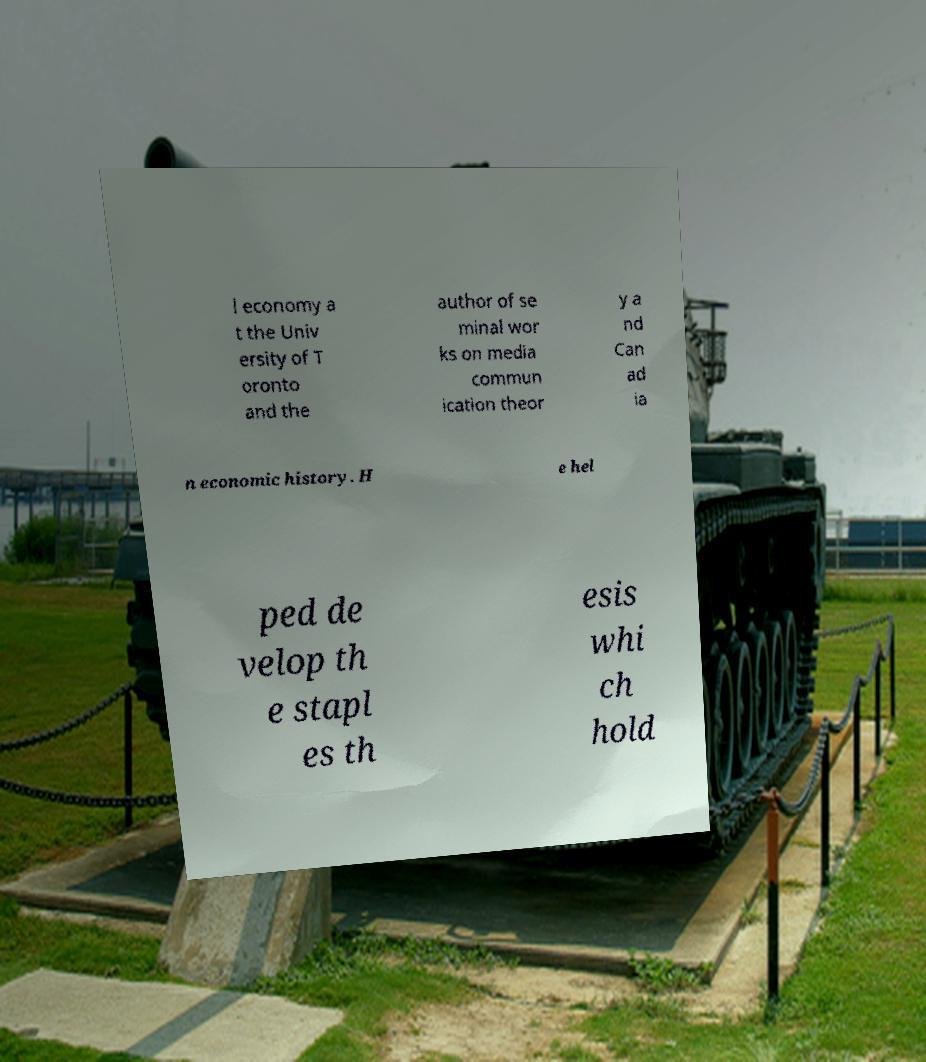Can you read and provide the text displayed in the image?This photo seems to have some interesting text. Can you extract and type it out for me? l economy a t the Univ ersity of T oronto and the author of se minal wor ks on media commun ication theor y a nd Can ad ia n economic history. H e hel ped de velop th e stapl es th esis whi ch hold 